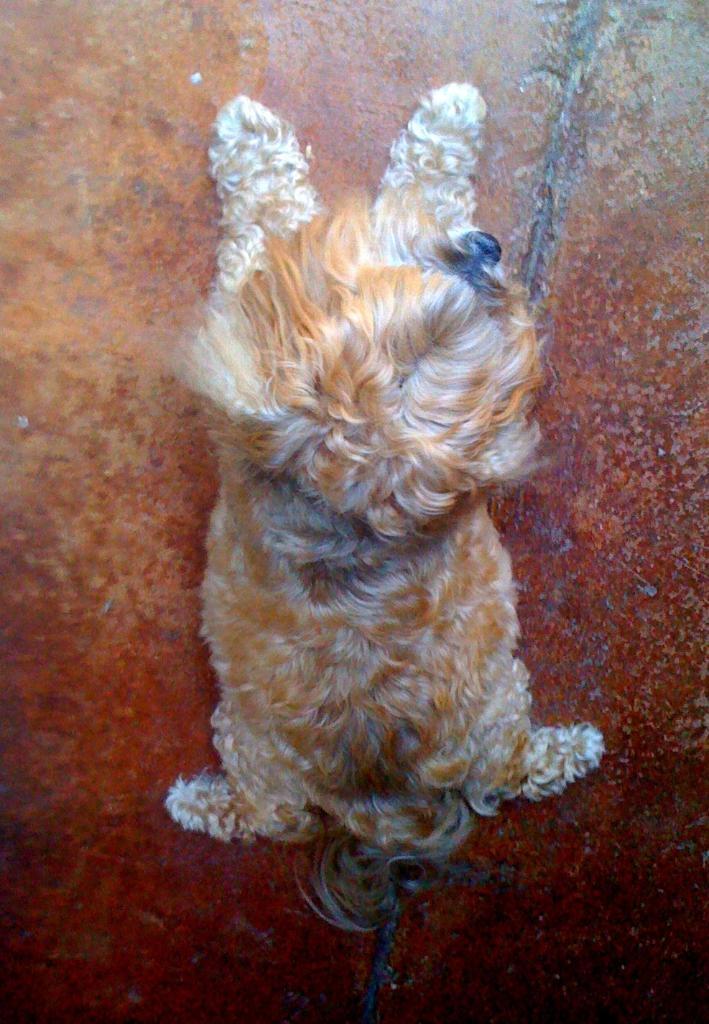Please provide a concise description of this image. In this image there is a dog sitting on the floor. 